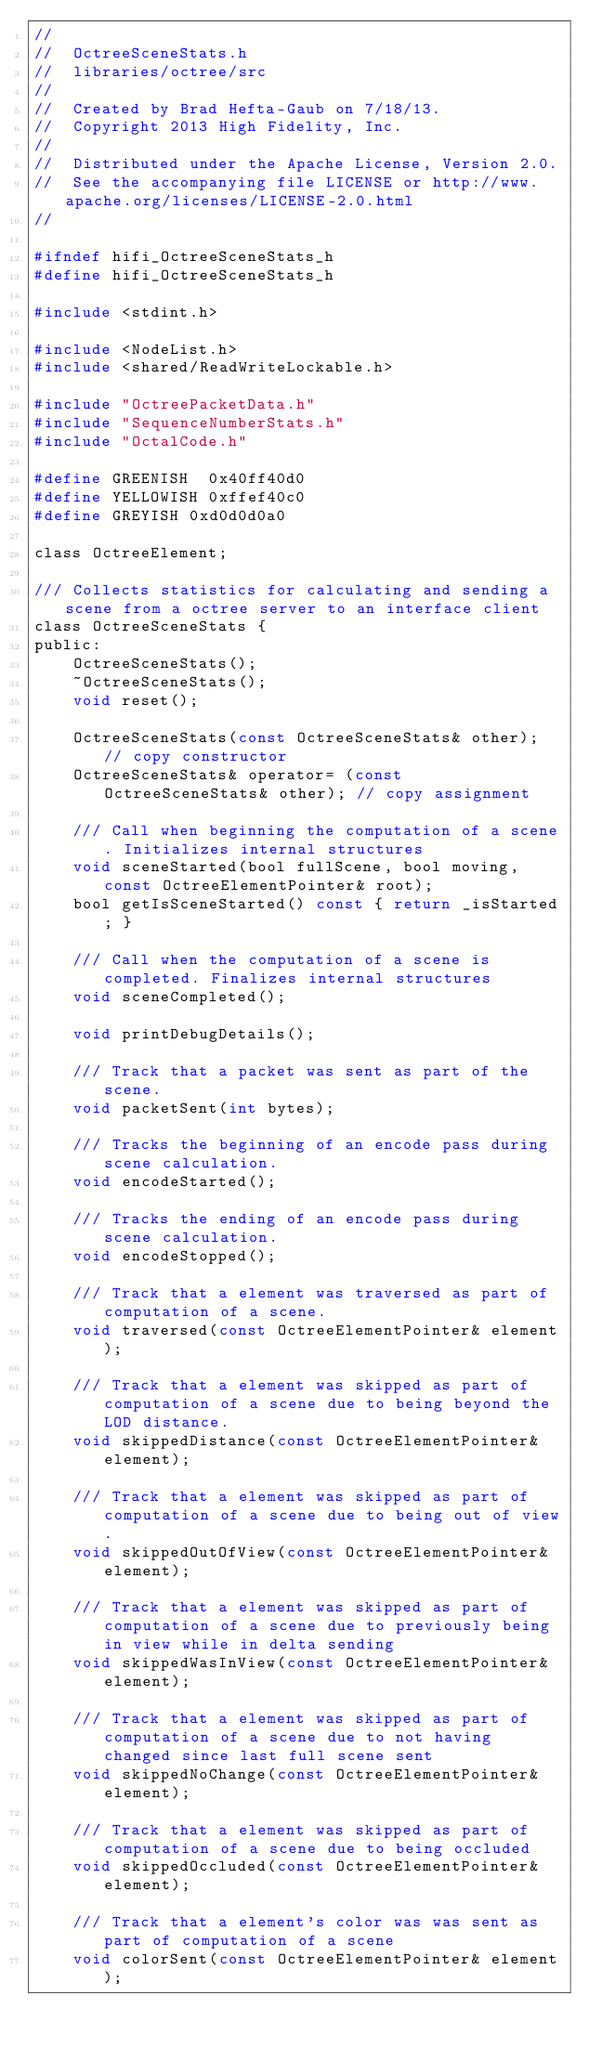<code> <loc_0><loc_0><loc_500><loc_500><_C_>//
//  OctreeSceneStats.h
//  libraries/octree/src
//
//  Created by Brad Hefta-Gaub on 7/18/13.
//  Copyright 2013 High Fidelity, Inc.
//
//  Distributed under the Apache License, Version 2.0.
//  See the accompanying file LICENSE or http://www.apache.org/licenses/LICENSE-2.0.html
//

#ifndef hifi_OctreeSceneStats_h
#define hifi_OctreeSceneStats_h

#include <stdint.h>

#include <NodeList.h>
#include <shared/ReadWriteLockable.h>

#include "OctreePacketData.h"
#include "SequenceNumberStats.h"
#include "OctalCode.h"

#define GREENISH  0x40ff40d0
#define YELLOWISH 0xffef40c0
#define GREYISH 0xd0d0d0a0

class OctreeElement;

/// Collects statistics for calculating and sending a scene from a octree server to an interface client
class OctreeSceneStats {
public:
    OctreeSceneStats();
    ~OctreeSceneStats();
    void reset();

    OctreeSceneStats(const OctreeSceneStats& other); // copy constructor
    OctreeSceneStats& operator= (const OctreeSceneStats& other); // copy assignment

    /// Call when beginning the computation of a scene. Initializes internal structures
    void sceneStarted(bool fullScene, bool moving, const OctreeElementPointer& root);
    bool getIsSceneStarted() const { return _isStarted; }

    /// Call when the computation of a scene is completed. Finalizes internal structures
    void sceneCompleted();

    void printDebugDetails();

    /// Track that a packet was sent as part of the scene.
    void packetSent(int bytes);

    /// Tracks the beginning of an encode pass during scene calculation.
    void encodeStarted();

    /// Tracks the ending of an encode pass during scene calculation.
    void encodeStopped();

    /// Track that a element was traversed as part of computation of a scene.
    void traversed(const OctreeElementPointer& element);

    /// Track that a element was skipped as part of computation of a scene due to being beyond the LOD distance.
    void skippedDistance(const OctreeElementPointer& element);

    /// Track that a element was skipped as part of computation of a scene due to being out of view.
    void skippedOutOfView(const OctreeElementPointer& element);

    /// Track that a element was skipped as part of computation of a scene due to previously being in view while in delta sending
    void skippedWasInView(const OctreeElementPointer& element);

    /// Track that a element was skipped as part of computation of a scene due to not having changed since last full scene sent
    void skippedNoChange(const OctreeElementPointer& element);

    /// Track that a element was skipped as part of computation of a scene due to being occluded
    void skippedOccluded(const OctreeElementPointer& element);

    /// Track that a element's color was was sent as part of computation of a scene
    void colorSent(const OctreeElementPointer& element);
</code> 